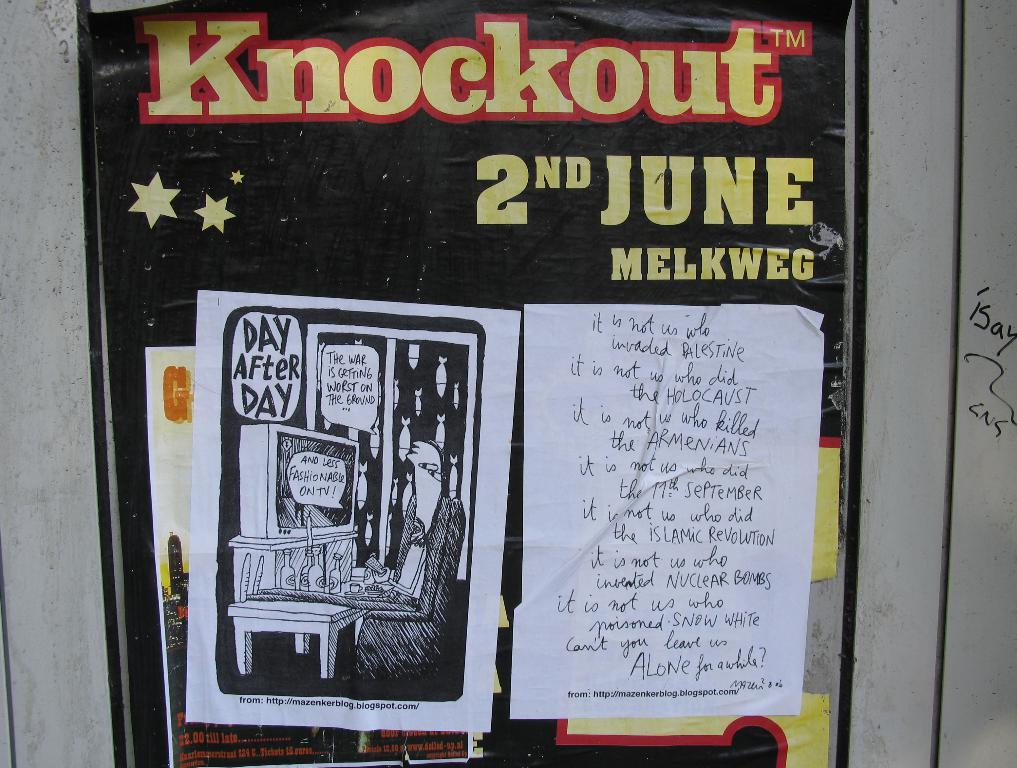What month is the knockout?
Provide a short and direct response. June. What day is knockout on?
Provide a short and direct response. June 2nd. 